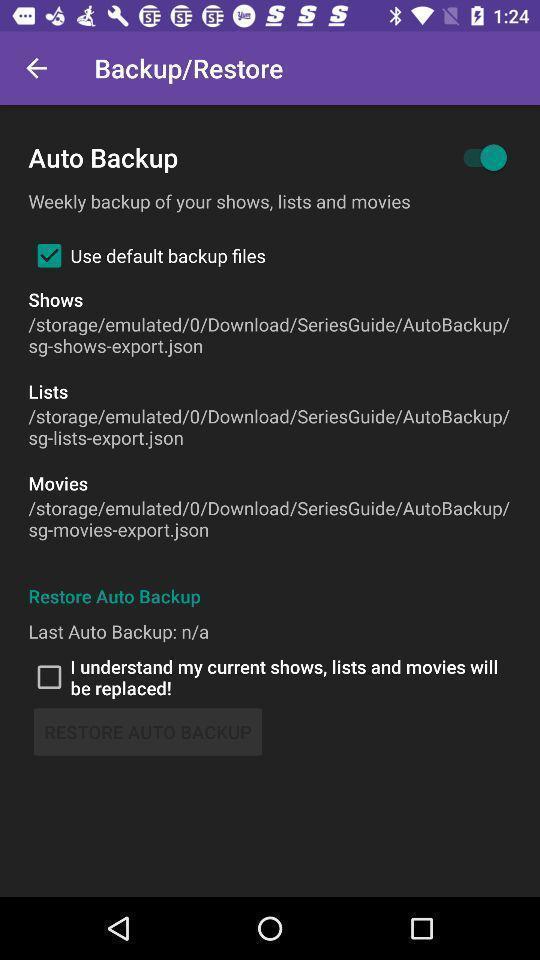Tell me what you see in this picture. Screen displaying toggle icon for backup setting. 